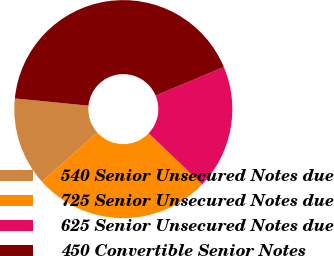Convert chart to OTSL. <chart><loc_0><loc_0><loc_500><loc_500><pie_chart><fcel>540 Senior Unsecured Notes due<fcel>725 Senior Unsecured Notes due<fcel>625 Senior Unsecured Notes due<fcel>450 Convertible Senior Notes<nl><fcel>13.15%<fcel>26.28%<fcel>18.44%<fcel>42.12%<nl></chart> 